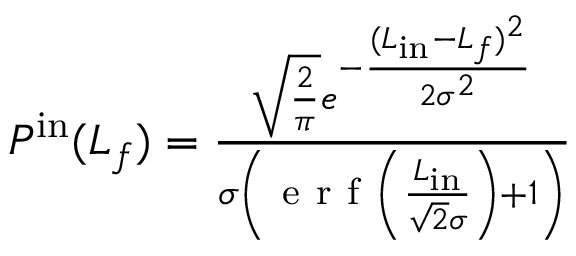Convert formula to latex. <formula><loc_0><loc_0><loc_500><loc_500>\begin{array} { r } { P ^ { i n } ( L _ { f } ) = \frac { \sqrt { \frac { 2 } { \pi } } e ^ { - \frac { ( L _ { i n } - L _ { f } ) ^ { 2 } } { 2 \sigma ^ { 2 } } } } { \sigma \left ( e r f \left ( \frac { L _ { i n } } { \sqrt { 2 } \sigma } \right ) + 1 \right ) } } \end{array}</formula> 